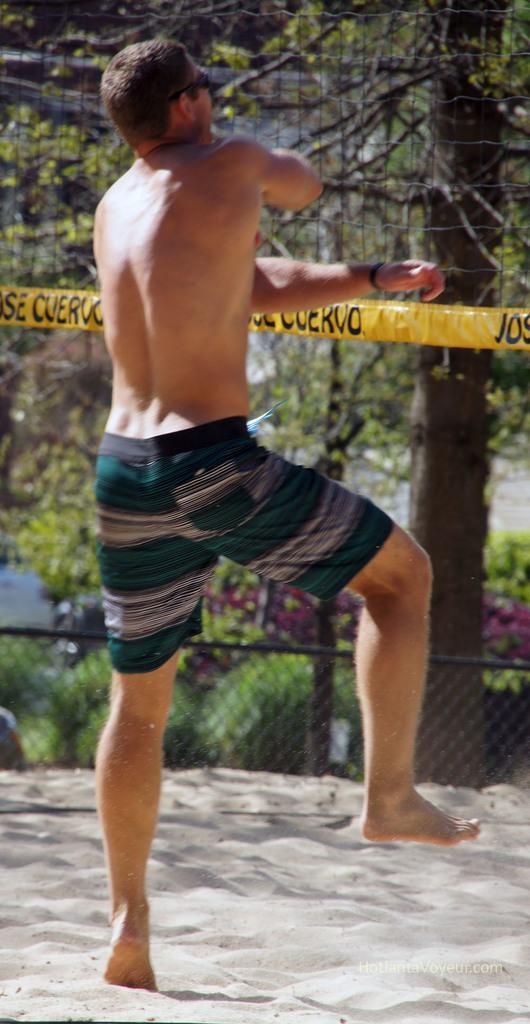Please provide a concise description of this image. In this image we can see a man. Here we can see sand, mesh, plants, trees, and an object. 